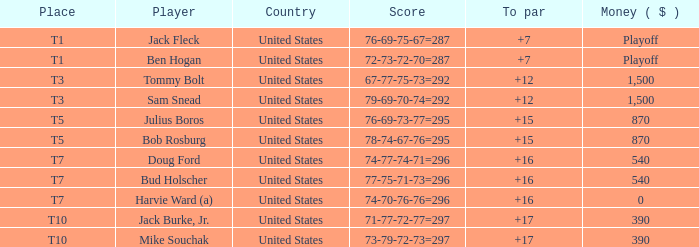What sum of money is associated with player jack fleck's t1 ranking? Playoff. 